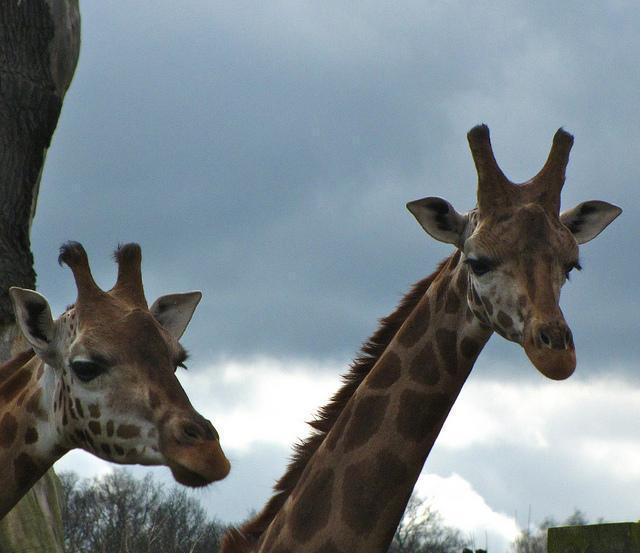How many giraffes can you see?
Give a very brief answer. 2. How many people are wearing sunglasses in this photo?
Give a very brief answer. 0. 